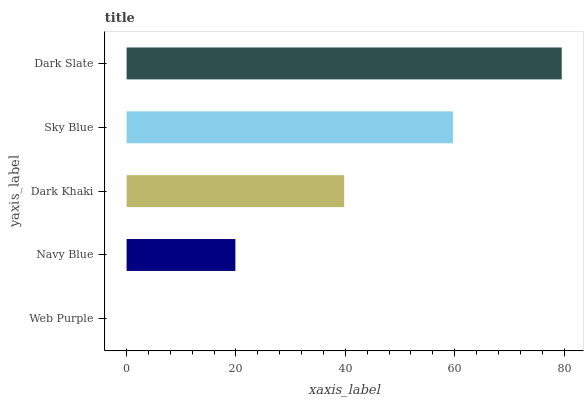Is Web Purple the minimum?
Answer yes or no. Yes. Is Dark Slate the maximum?
Answer yes or no. Yes. Is Navy Blue the minimum?
Answer yes or no. No. Is Navy Blue the maximum?
Answer yes or no. No. Is Navy Blue greater than Web Purple?
Answer yes or no. Yes. Is Web Purple less than Navy Blue?
Answer yes or no. Yes. Is Web Purple greater than Navy Blue?
Answer yes or no. No. Is Navy Blue less than Web Purple?
Answer yes or no. No. Is Dark Khaki the high median?
Answer yes or no. Yes. Is Dark Khaki the low median?
Answer yes or no. Yes. Is Web Purple the high median?
Answer yes or no. No. Is Navy Blue the low median?
Answer yes or no. No. 